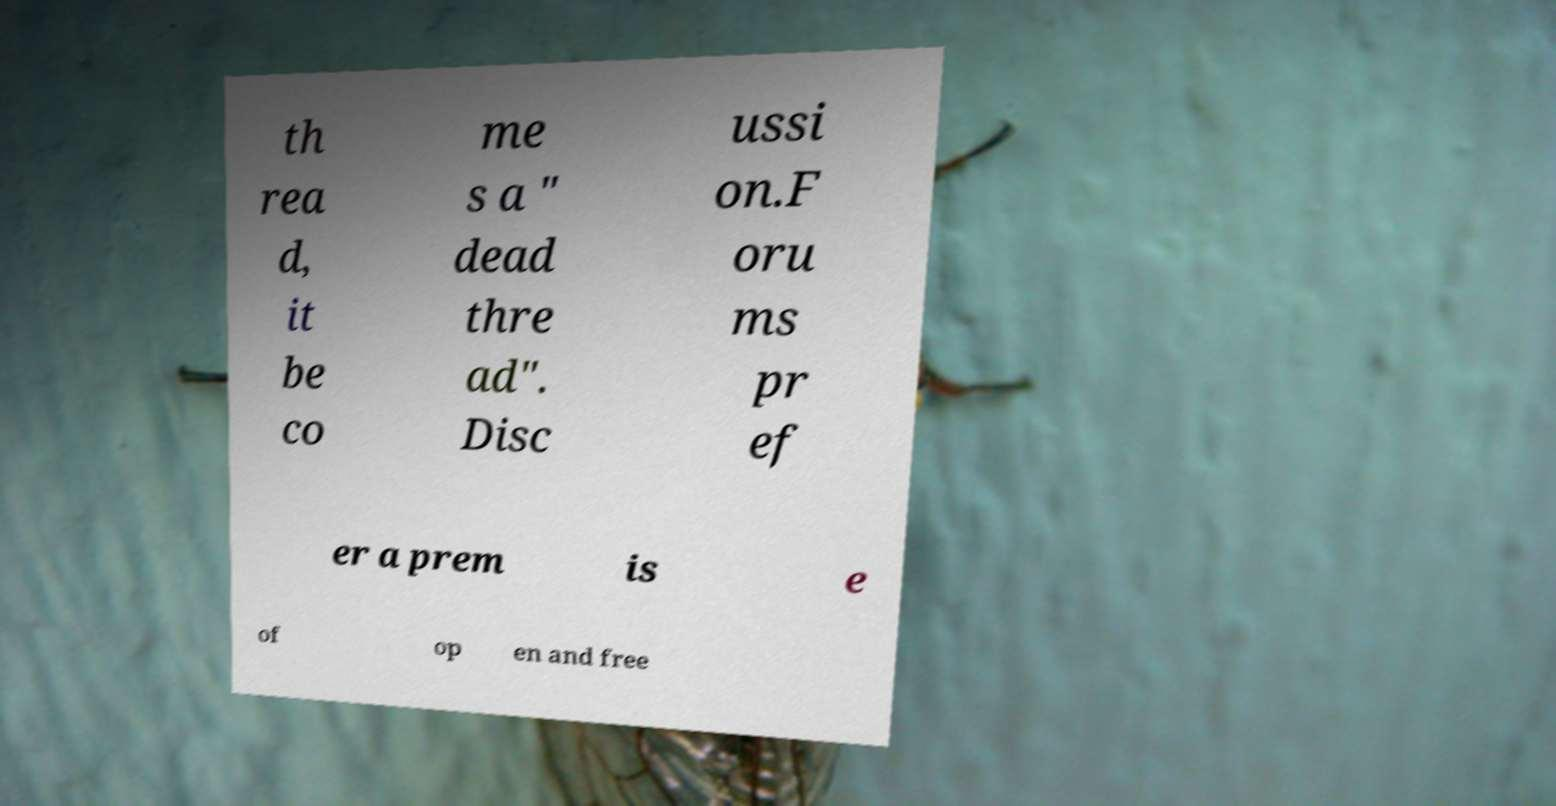I need the written content from this picture converted into text. Can you do that? th rea d, it be co me s a " dead thre ad". Disc ussi on.F oru ms pr ef er a prem is e of op en and free 